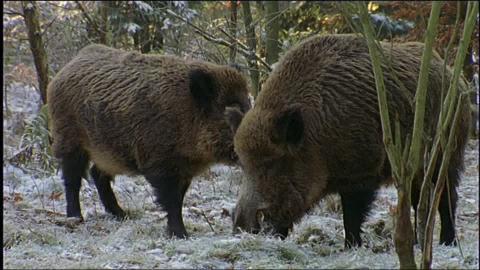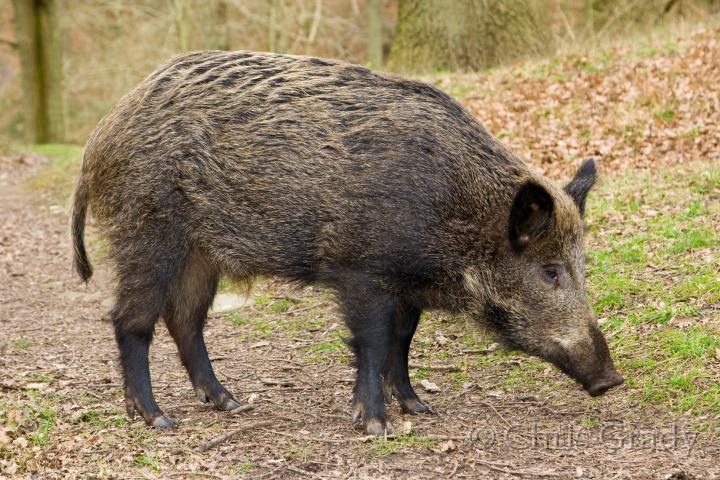The first image is the image on the left, the second image is the image on the right. Given the left and right images, does the statement "At least one image features multiple full grown warthogs." hold true? Answer yes or no. Yes. 